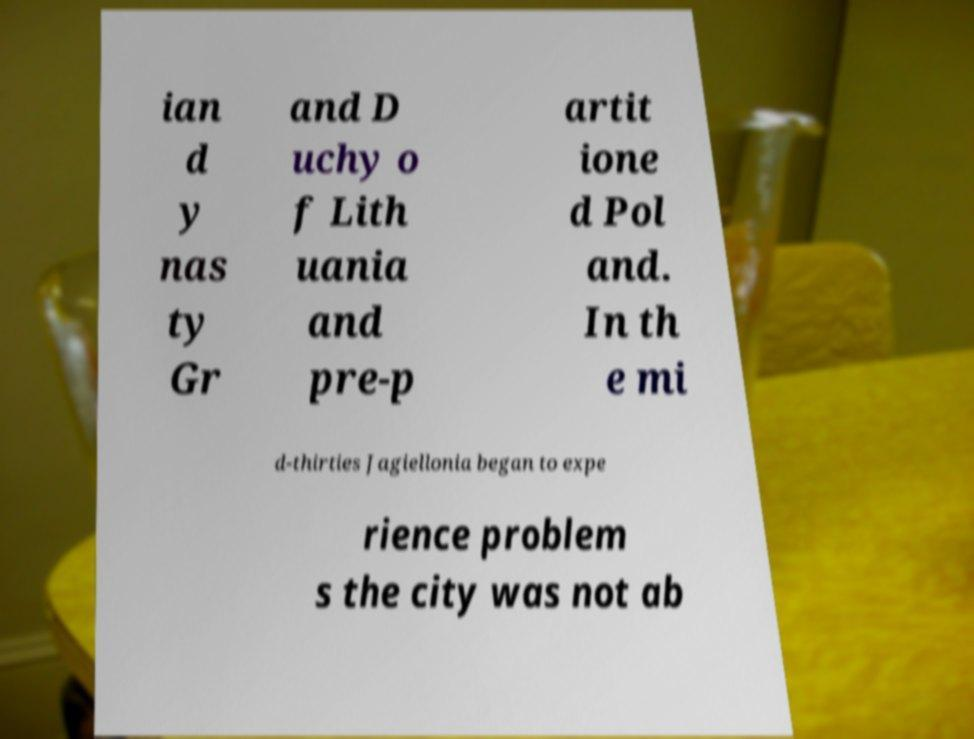Could you extract and type out the text from this image? ian d y nas ty Gr and D uchy o f Lith uania and pre-p artit ione d Pol and. In th e mi d-thirties Jagiellonia began to expe rience problem s the city was not ab 